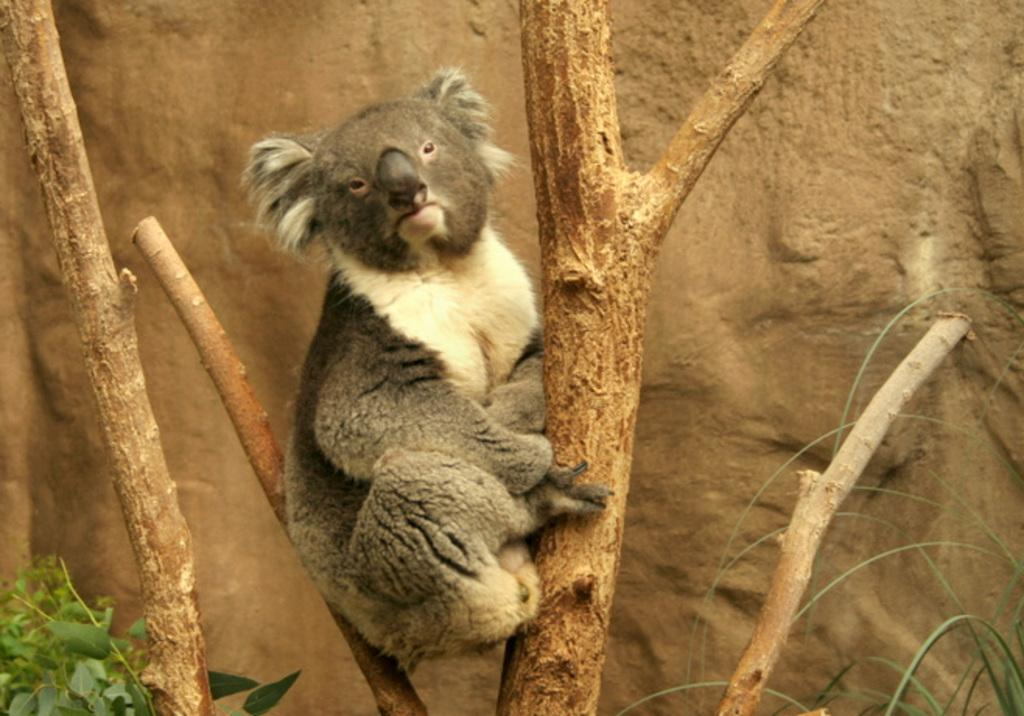What animal is in the image? There is a koala in the image. Where is the koala located? The koala is on a tree trunk. What else can be seen at the bottom of the image? A few leaves are visible at the bottom of the image. What is present in the background of the image? There is a rock in the background of the image. What type of books can be seen in the image? There are no books present in the image; it features a koala on a tree trunk. Is there a fire visible in the image? There is no fire present in the image. 